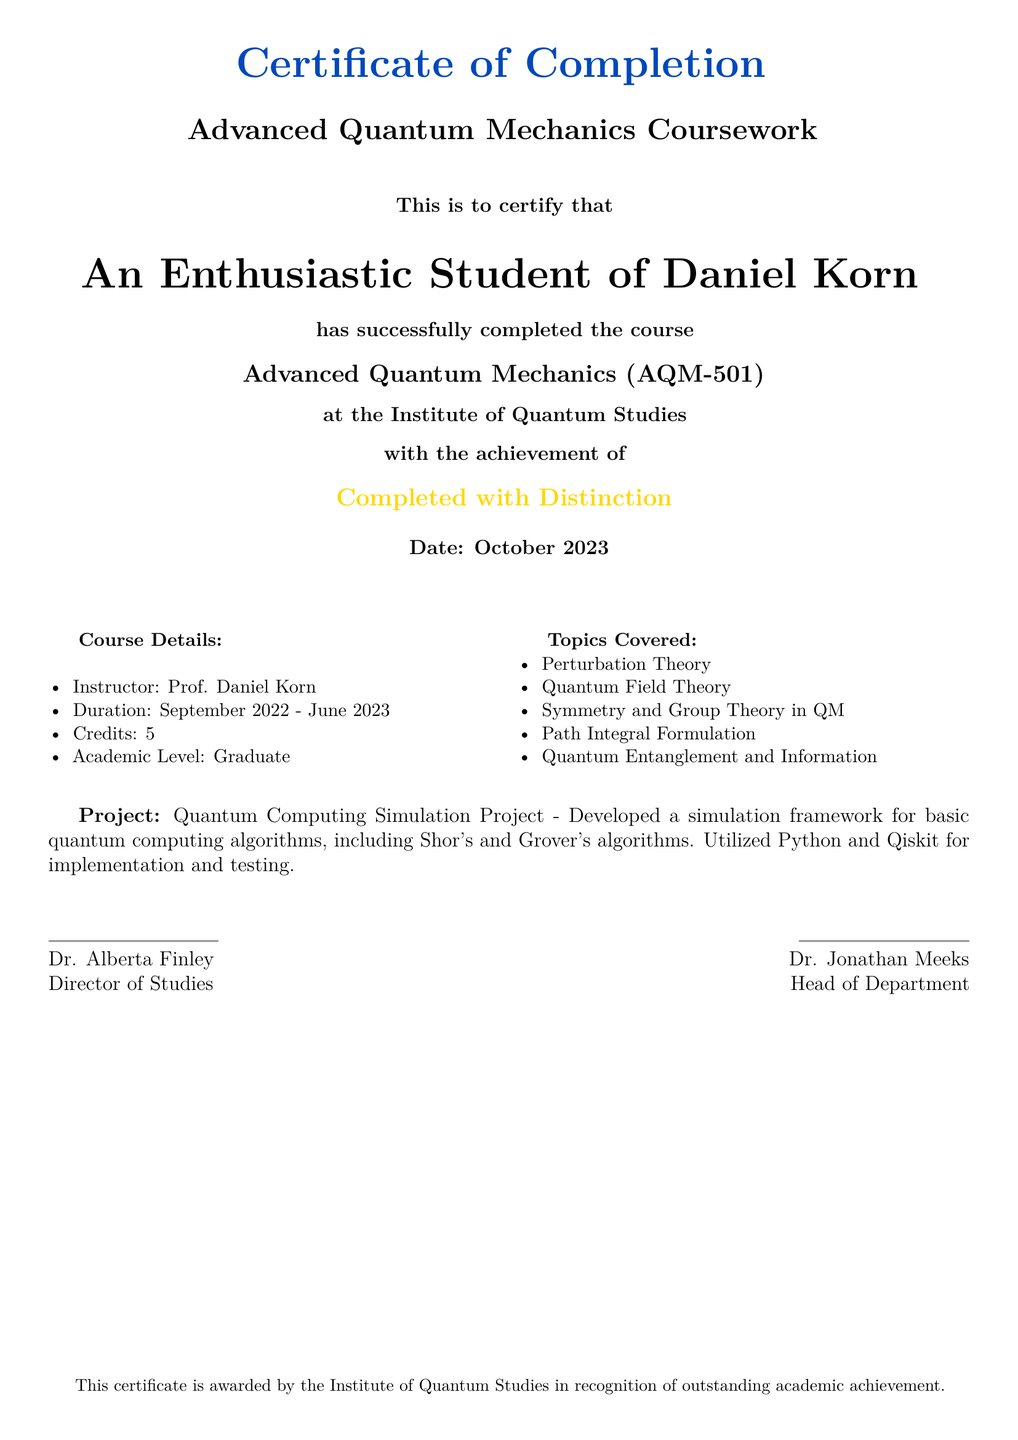What is the name of the student? The student's name is presented prominently in the certificate as "An Enthusiastic Student of Daniel Korn."
Answer: An Enthusiastic Student of Daniel Korn What is the course title? The title of the course is stated clearly in the document as "Advanced Quantum Mechanics (AQM-501)."
Answer: Advanced Quantum Mechanics (AQM-501) Who was the instructor? The instructor's name is listed in the course details section: "Prof. Daniel Korn."
Answer: Prof. Daniel Korn What is the date of completion? The date of completion is specified at the bottom of the certificate as "October 2023."
Answer: October 2023 What achievement did the student receive? The certificate indicates the achievement as "Completed with Distinction."
Answer: Completed with Distinction What was the project completed during the course? The document describes the project as "Quantum Computing Simulation Project."
Answer: Quantum Computing Simulation Project How many credits were awarded for the course? The credits awarded for the course are specified as "5."
Answer: 5 What was the duration of the course? The duration of the course is given as "September 2022 - June 2023."
Answer: September 2022 - June 2023 Who is the Director of Studies? The name of the Director of Studies is provided as "Dr. Alberta Finley."
Answer: Dr. Alberta Finley 